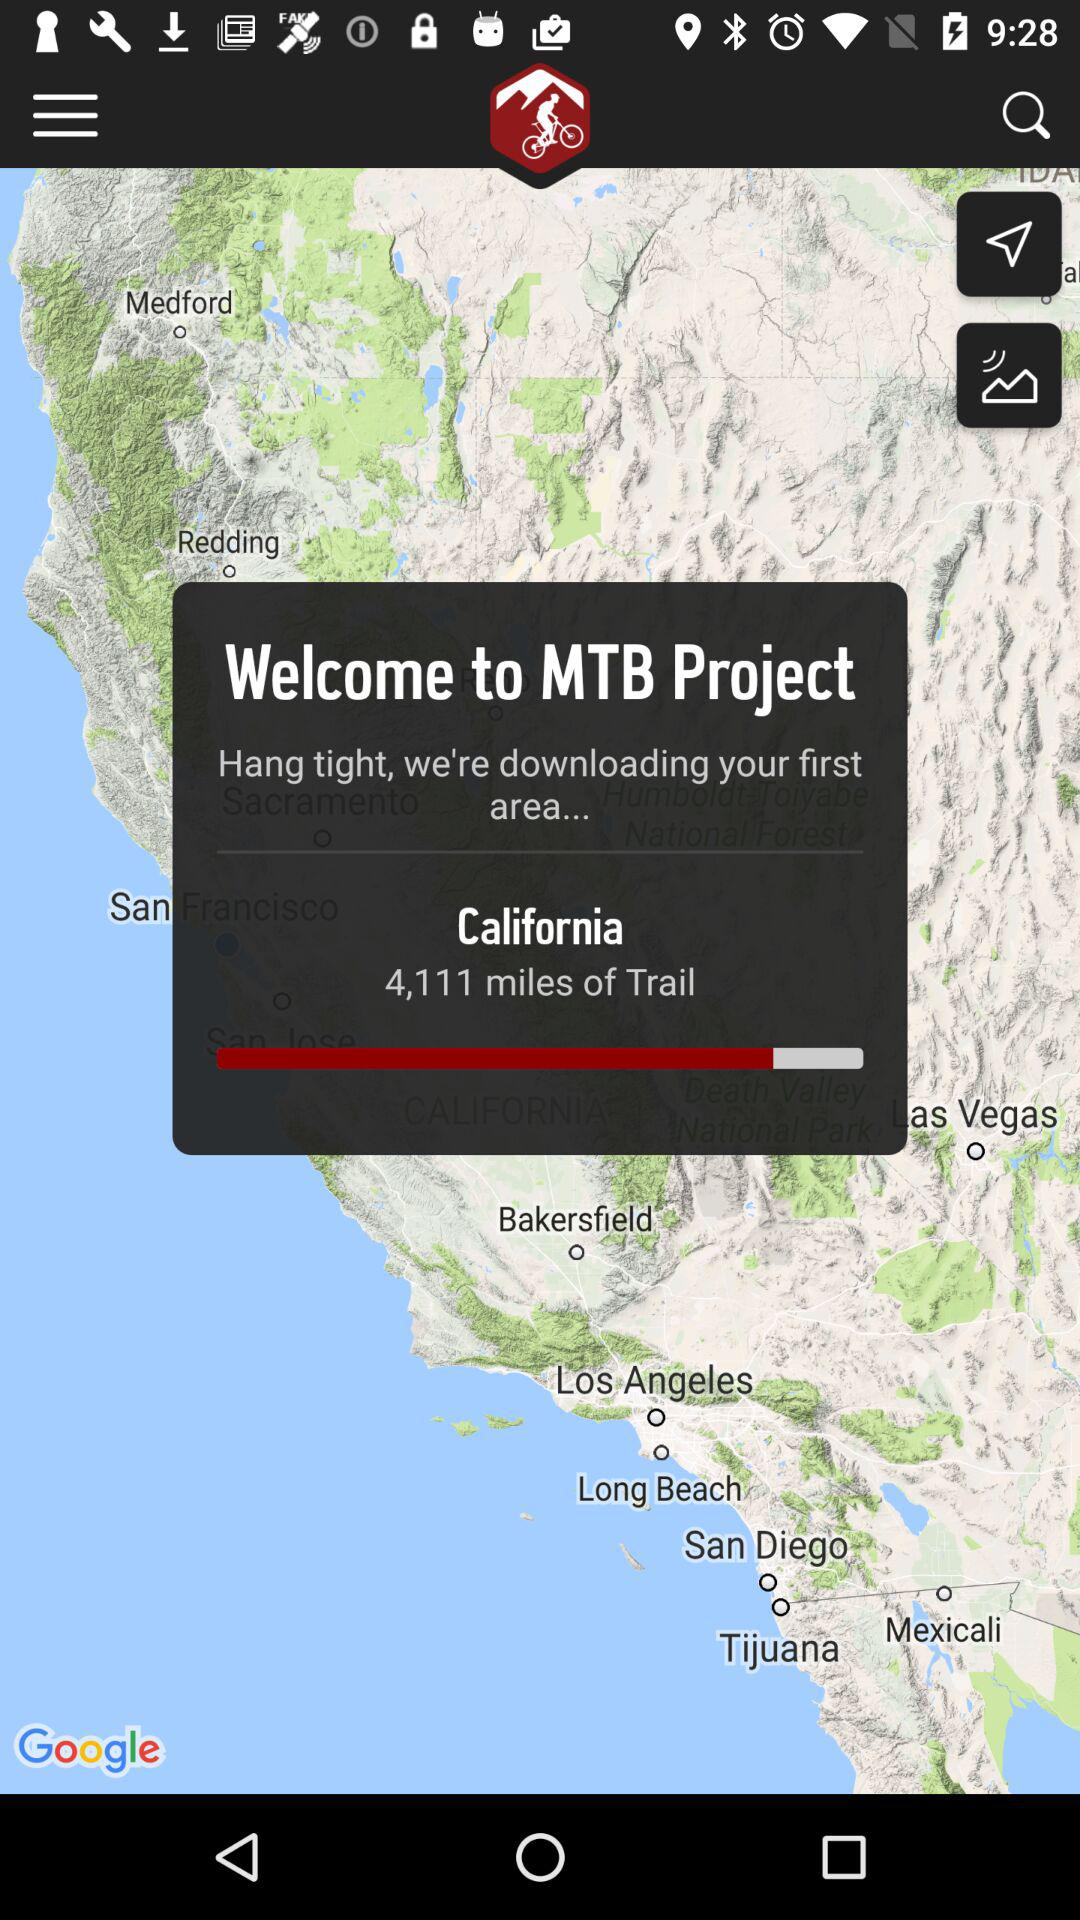How far is the trail from California? It is 4,111 miles away. 